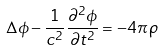<formula> <loc_0><loc_0><loc_500><loc_500>\Delta \phi - \frac { 1 } { c ^ { 2 } } \frac { \partial ^ { 2 } \phi } { \partial t ^ { 2 } } = - 4 \pi \, \rho</formula> 